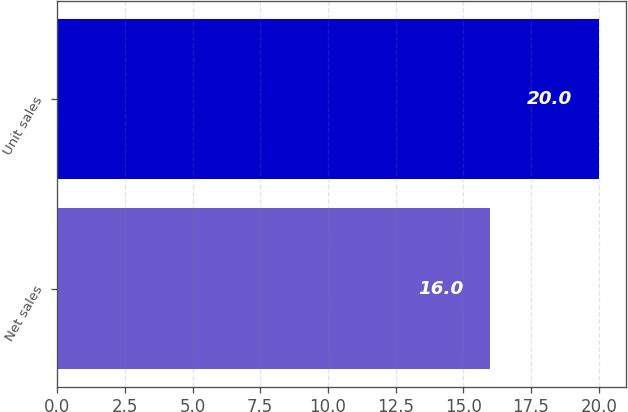<chart> <loc_0><loc_0><loc_500><loc_500><bar_chart><fcel>Net sales<fcel>Unit sales<nl><fcel>16<fcel>20<nl></chart> 